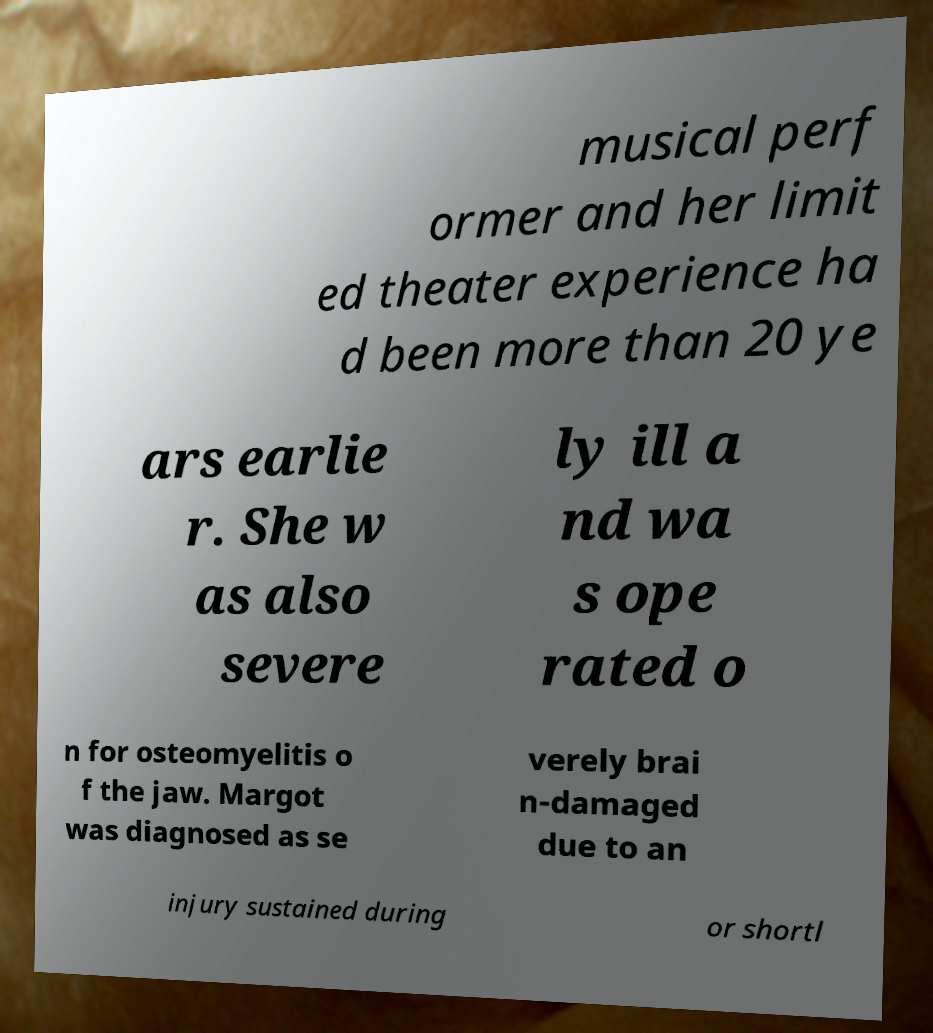I need the written content from this picture converted into text. Can you do that? musical perf ormer and her limit ed theater experience ha d been more than 20 ye ars earlie r. She w as also severe ly ill a nd wa s ope rated o n for osteomyelitis o f the jaw. Margot was diagnosed as se verely brai n-damaged due to an injury sustained during or shortl 